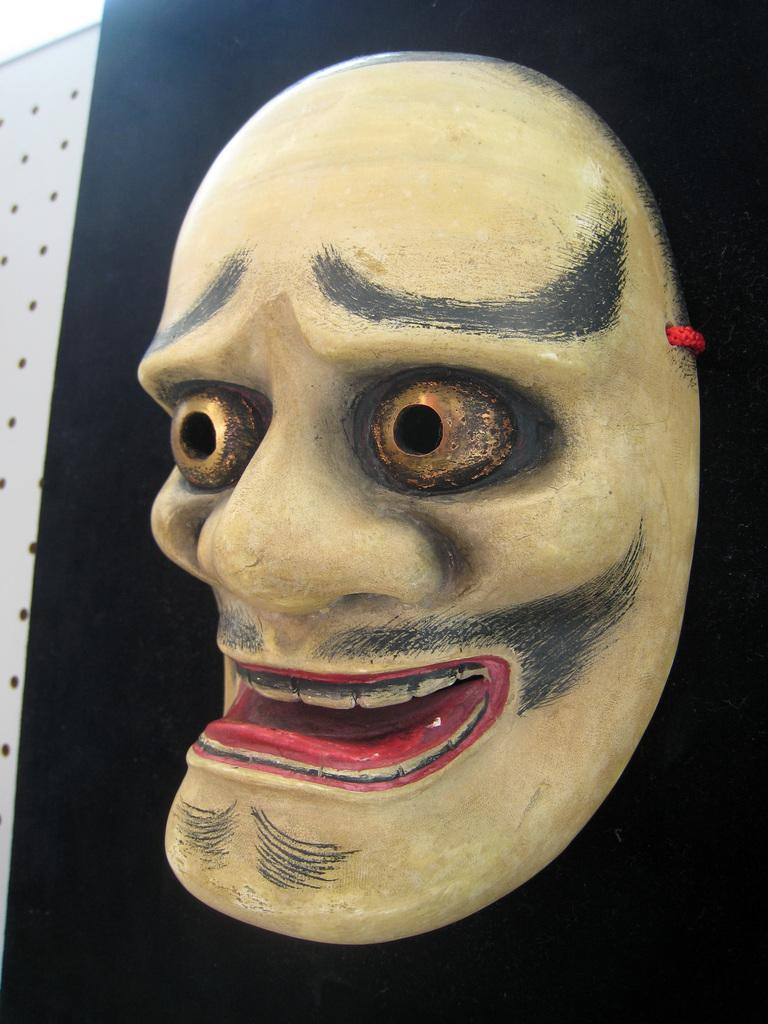What is the main subject in the center of the image? There is a mask in the center of the image. What color is the paper in the background of the image? The paper in the background of the image is black. How many fish can be seen swimming on the black paper in the image? There are no fish present in the image; it only features a mask and black paper in the background. What type of star is visible on the mask in the image? There is no star depicted on the mask in the image; it is a mask without any additional details. 